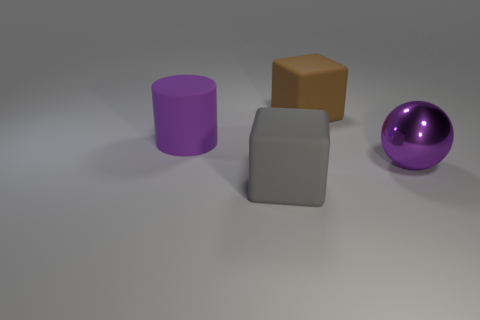Is the large gray thing made of the same material as the purple ball?
Your response must be concise. No. Do the large shiny sphere that is in front of the cylinder and the rubber cylinder have the same color?
Provide a succinct answer. Yes. The block in front of the purple object left of the big cube that is behind the big purple rubber cylinder is made of what material?
Provide a succinct answer. Rubber. Is there a cylinder of the same color as the shiny ball?
Make the answer very short. Yes. Are there fewer purple balls to the right of the metal sphere than purple things?
Provide a short and direct response. Yes. What number of rubber objects are both behind the purple sphere and on the left side of the brown matte thing?
Your answer should be very brief. 1. What size is the rubber thing that is left of the cube in front of the metallic thing?
Make the answer very short. Large. Are there fewer rubber blocks that are in front of the gray block than big matte cubes that are left of the big brown object?
Offer a very short reply. Yes. Do the cylinder that is in front of the brown rubber object and the big thing right of the brown matte object have the same color?
Provide a succinct answer. Yes. There is a thing that is behind the metallic thing and right of the purple rubber thing; what is its material?
Ensure brevity in your answer.  Rubber. 